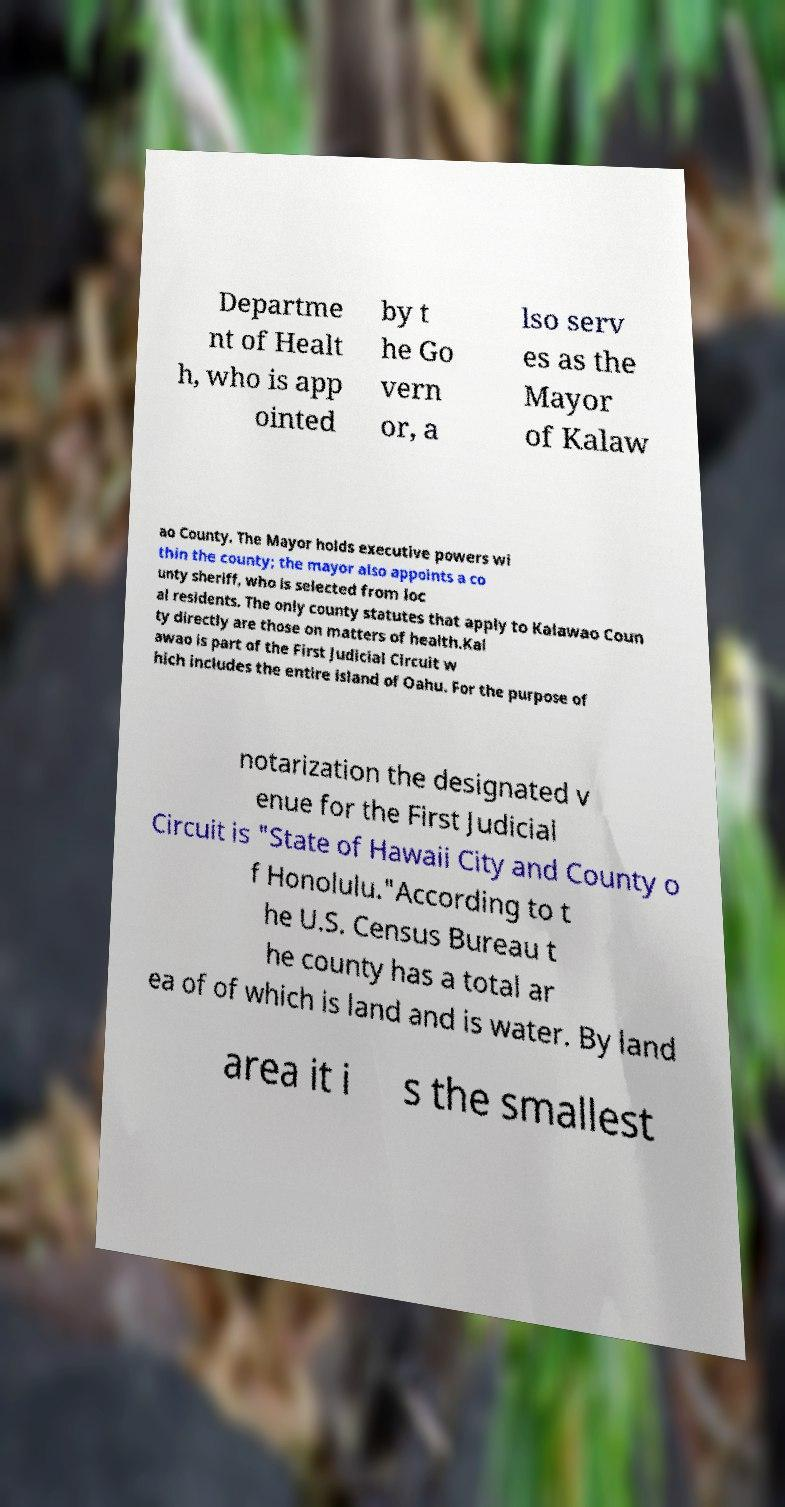There's text embedded in this image that I need extracted. Can you transcribe it verbatim? Departme nt of Healt h, who is app ointed by t he Go vern or, a lso serv es as the Mayor of Kalaw ao County. The Mayor holds executive powers wi thin the county; the mayor also appoints a co unty sheriff, who is selected from loc al residents. The only county statutes that apply to Kalawao Coun ty directly are those on matters of health.Kal awao is part of the First Judicial Circuit w hich includes the entire island of Oahu. For the purpose of notarization the designated v enue for the First Judicial Circuit is "State of Hawaii City and County o f Honolulu."According to t he U.S. Census Bureau t he county has a total ar ea of of which is land and is water. By land area it i s the smallest 